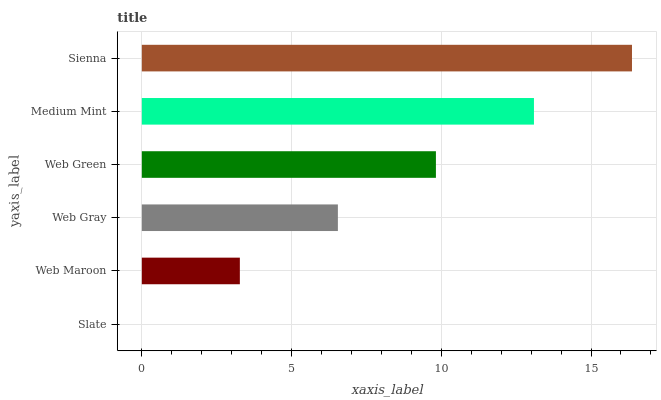Is Slate the minimum?
Answer yes or no. Yes. Is Sienna the maximum?
Answer yes or no. Yes. Is Web Maroon the minimum?
Answer yes or no. No. Is Web Maroon the maximum?
Answer yes or no. No. Is Web Maroon greater than Slate?
Answer yes or no. Yes. Is Slate less than Web Maroon?
Answer yes or no. Yes. Is Slate greater than Web Maroon?
Answer yes or no. No. Is Web Maroon less than Slate?
Answer yes or no. No. Is Web Green the high median?
Answer yes or no. Yes. Is Web Gray the low median?
Answer yes or no. Yes. Is Web Maroon the high median?
Answer yes or no. No. Is Web Maroon the low median?
Answer yes or no. No. 